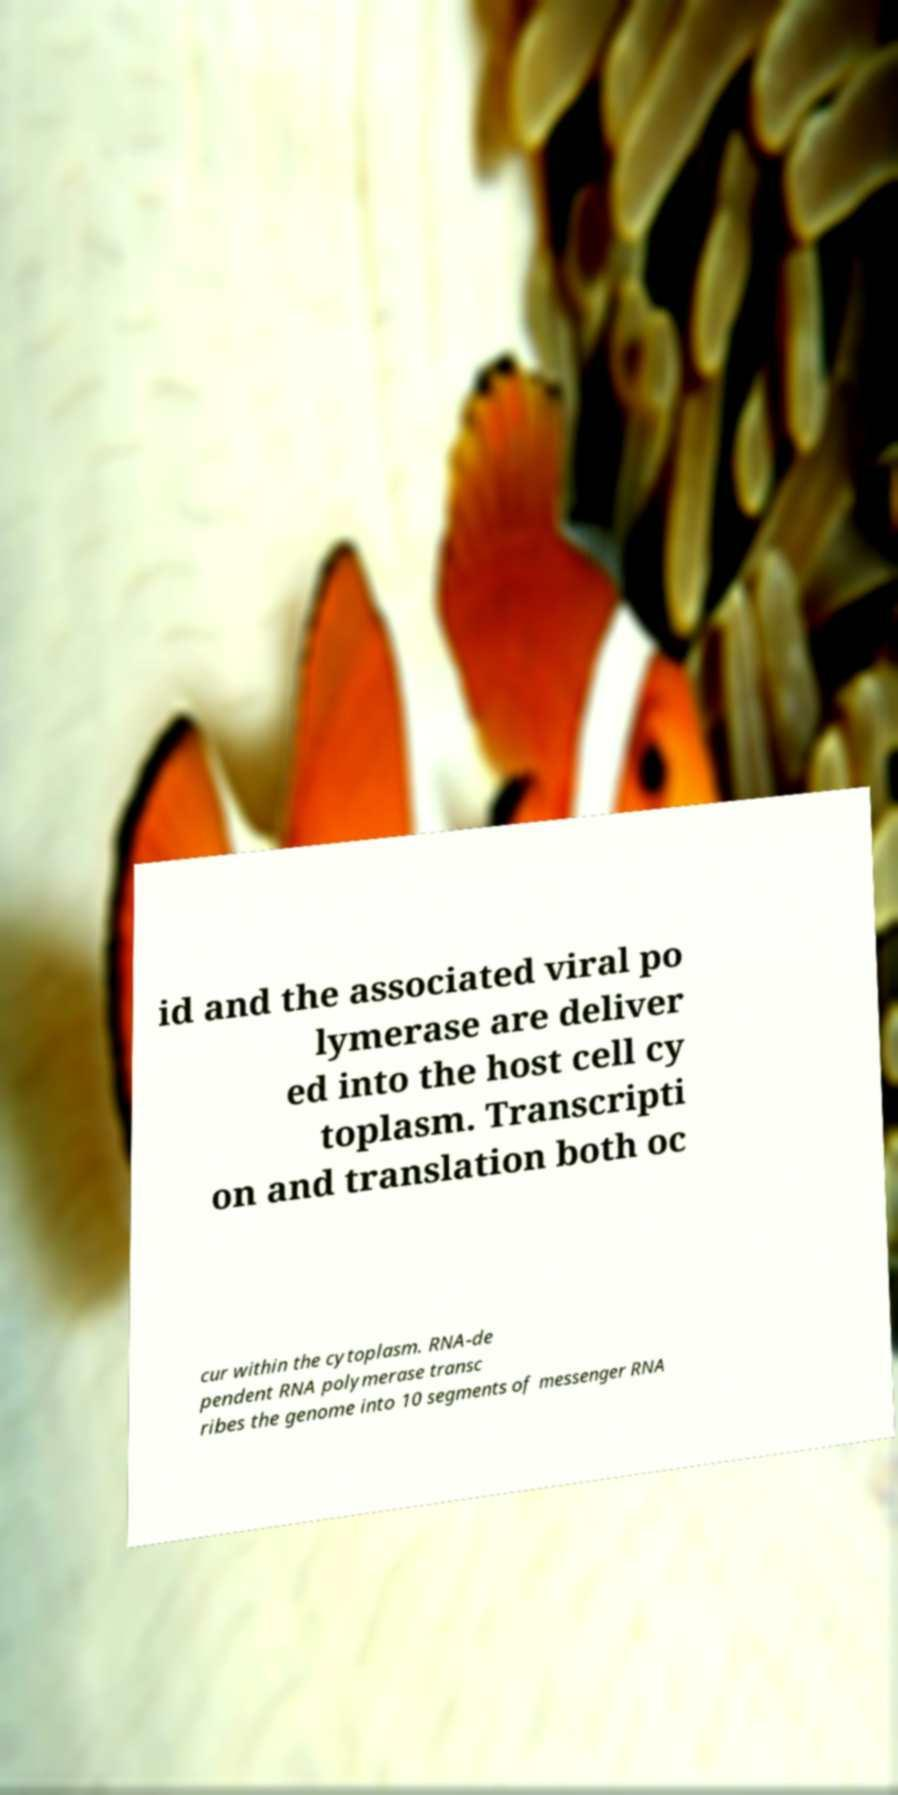There's text embedded in this image that I need extracted. Can you transcribe it verbatim? id and the associated viral po lymerase are deliver ed into the host cell cy toplasm. Transcripti on and translation both oc cur within the cytoplasm. RNA-de pendent RNA polymerase transc ribes the genome into 10 segments of messenger RNA 